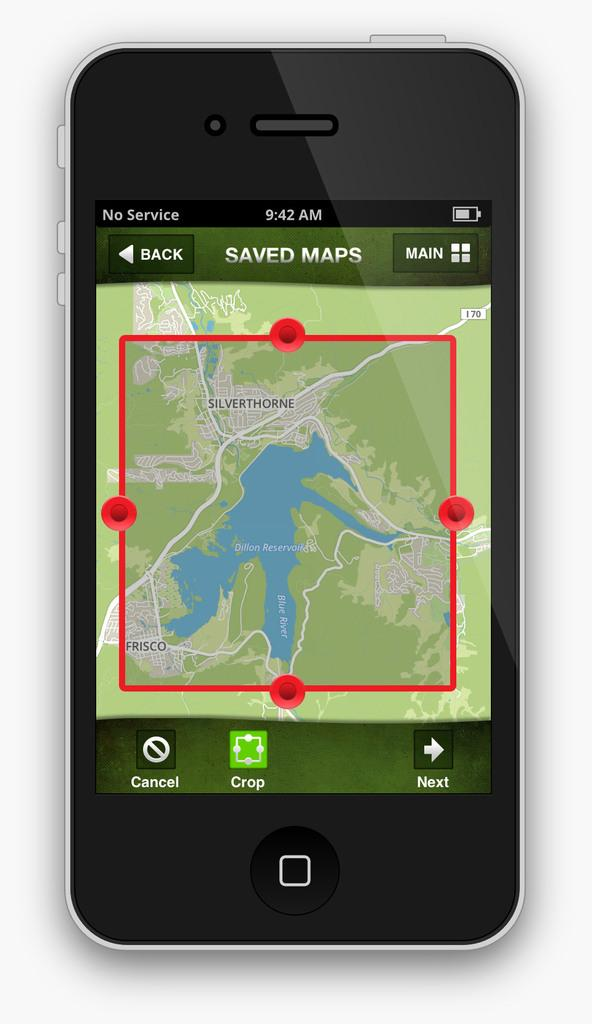<image>
Offer a succinct explanation of the picture presented. A phone's screen display has a map of Silverthorne up 